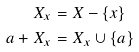Convert formula to latex. <formula><loc_0><loc_0><loc_500><loc_500>X _ { x } & = X - \{ x \} \\ a + X _ { x } & = X _ { x } \cup \{ a \}</formula> 